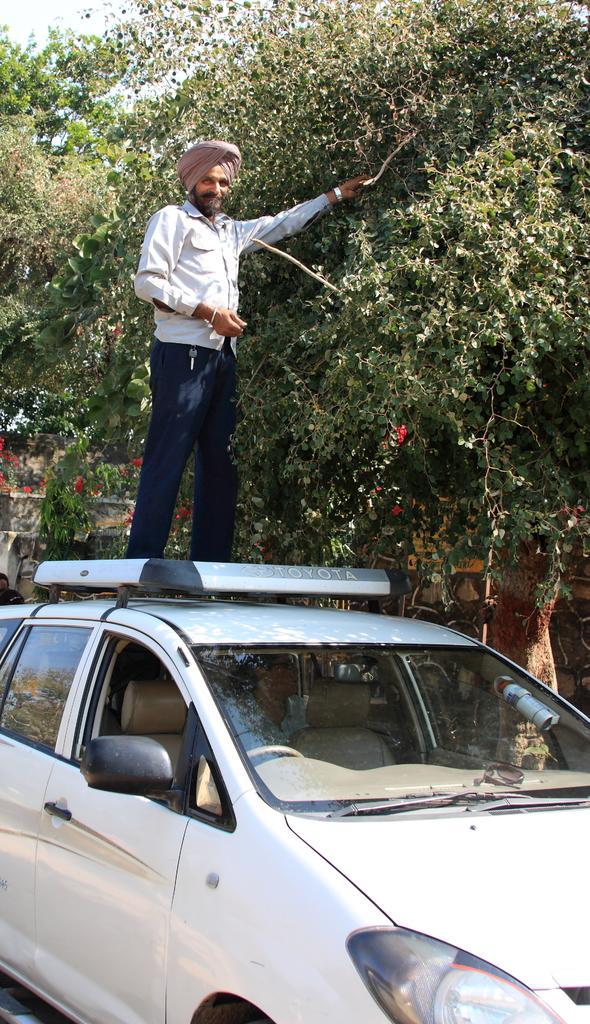Could you give a brief overview of what you see in this image? Here we can see a man standing on the car. In the background we can see trees and sky. 